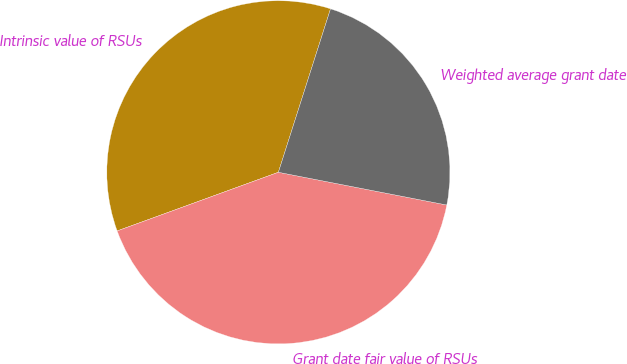Convert chart to OTSL. <chart><loc_0><loc_0><loc_500><loc_500><pie_chart><fcel>Intrinsic value of RSUs<fcel>Grant date fair value of RSUs<fcel>Weighted average grant date<nl><fcel>35.47%<fcel>41.39%<fcel>23.14%<nl></chart> 